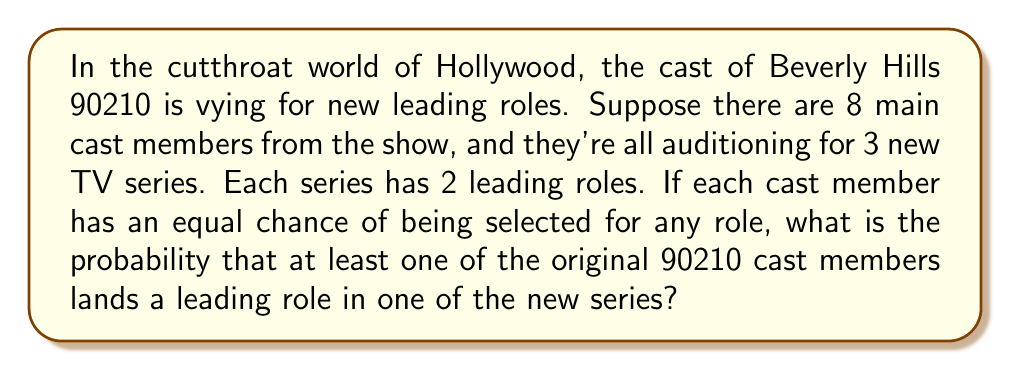Show me your answer to this math problem. Let's approach this step-by-step:

1) First, let's calculate the total number of leading roles available:
   3 series × 2 leading roles per series = 6 total leading roles

2) Now, let's consider the probability of none of the 90210 cast members getting a role. This is easier to calculate than the probability of at least one getting a role.

3) For each role, the probability of a 90210 cast member not getting it is:
   $\frac{8}{8} - \frac{8}{8} = 1 - \frac{8}{8} = 0$

4) For all 6 roles to be filled without any 90210 cast member, this needs to happen 6 times independently. So the probability is:

   $$(1 - \frac{8}{8})^6 = 0^6 = 0$$

5) Therefore, the probability of at least one 90210 cast member getting a role is:

   $$1 - (1 - \frac{8}{8})^6 = 1 - 0 = 1$$

This means it's certain that at least one 90210 cast member will get a leading role.

However, this result is due to the assumption that each cast member has an equal chance of being selected for any role, which isn't realistic. In a more realistic scenario, we would need to consider factors like individual talent, typecasting, and industry connections.
Answer: The probability is 1, or 100%. 